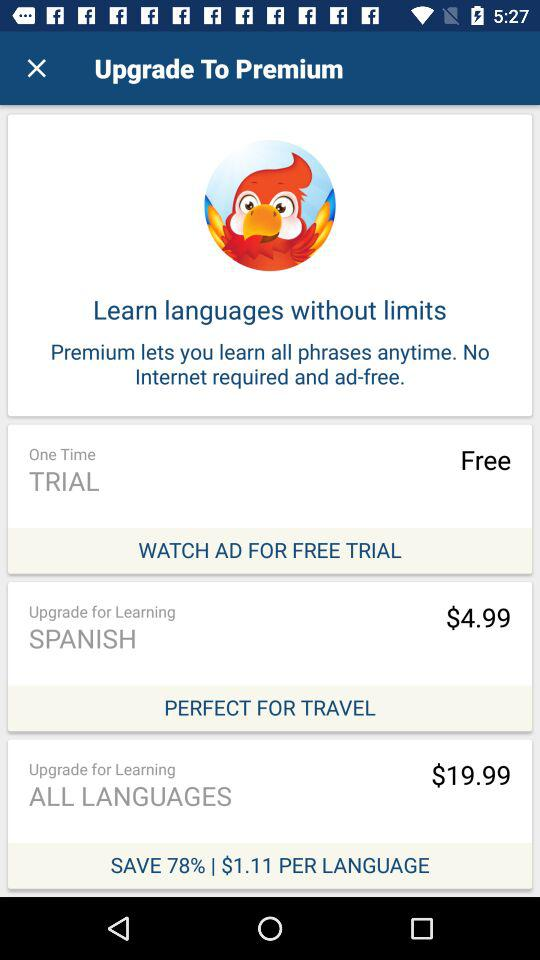What is the currency of an amount? The currency is dollars. 